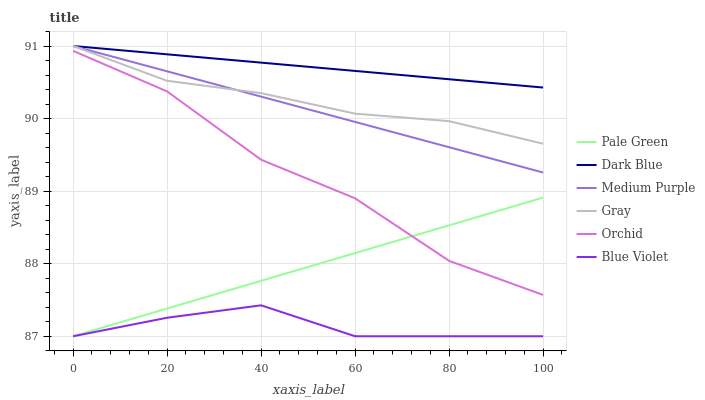Does Blue Violet have the minimum area under the curve?
Answer yes or no. Yes. Does Dark Blue have the maximum area under the curve?
Answer yes or no. Yes. Does Medium Purple have the minimum area under the curve?
Answer yes or no. No. Does Medium Purple have the maximum area under the curve?
Answer yes or no. No. Is Pale Green the smoothest?
Answer yes or no. Yes. Is Orchid the roughest?
Answer yes or no. Yes. Is Medium Purple the smoothest?
Answer yes or no. No. Is Medium Purple the roughest?
Answer yes or no. No. Does Pale Green have the lowest value?
Answer yes or no. Yes. Does Medium Purple have the lowest value?
Answer yes or no. No. Does Dark Blue have the highest value?
Answer yes or no. Yes. Does Pale Green have the highest value?
Answer yes or no. No. Is Orchid less than Dark Blue?
Answer yes or no. Yes. Is Dark Blue greater than Blue Violet?
Answer yes or no. Yes. Does Gray intersect Dark Blue?
Answer yes or no. Yes. Is Gray less than Dark Blue?
Answer yes or no. No. Is Gray greater than Dark Blue?
Answer yes or no. No. Does Orchid intersect Dark Blue?
Answer yes or no. No. 